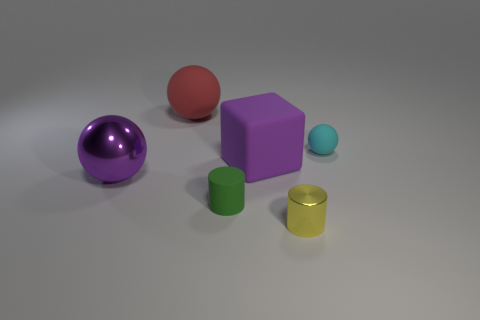How many other objects are there of the same material as the small cyan ball?
Make the answer very short. 3. What color is the large object that is behind the metallic ball and on the left side of the small matte cylinder?
Offer a very short reply. Red. How many things are either rubber things to the left of the tiny green rubber cylinder or big cyan objects?
Offer a terse response. 1. How many other objects are there of the same color as the large metallic object?
Offer a terse response. 1. Are there an equal number of matte cubes left of the large purple rubber object and purple rubber cubes?
Give a very brief answer. No. What number of small objects are behind the tiny thing right of the thing that is in front of the green rubber object?
Provide a succinct answer. 0. Are there any other things that have the same size as the green object?
Your response must be concise. Yes. Is the size of the purple metal thing the same as the green matte cylinder left of the large purple cube?
Your answer should be very brief. No. How many big purple blocks are there?
Provide a succinct answer. 1. Does the metal object that is to the right of the purple shiny sphere have the same size as the purple thing to the left of the tiny green rubber object?
Ensure brevity in your answer.  No. 